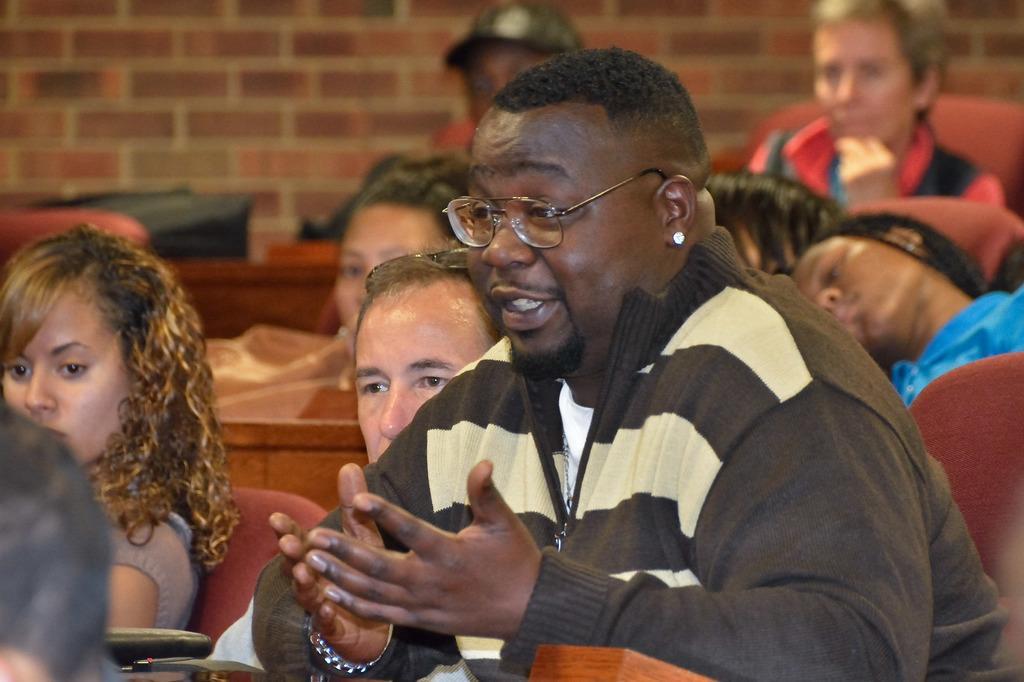Please provide a concise description of this image. In this image I can see people are sitting on chairs among them this man is wearing spectacles and jacket. In the background I can see the wall. 